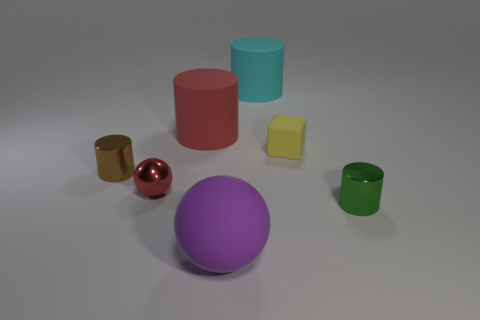Subtract all red rubber cylinders. How many cylinders are left? 3 Subtract all green cylinders. How many cylinders are left? 3 Add 1 tiny brown shiny objects. How many objects exist? 8 Add 7 large cylinders. How many large cylinders exist? 9 Subtract 1 red cylinders. How many objects are left? 6 Subtract all spheres. How many objects are left? 5 Subtract 1 blocks. How many blocks are left? 0 Subtract all purple blocks. Subtract all green balls. How many blocks are left? 1 Subtract all purple balls. How many green cylinders are left? 1 Subtract all cyan cylinders. Subtract all red matte cylinders. How many objects are left? 5 